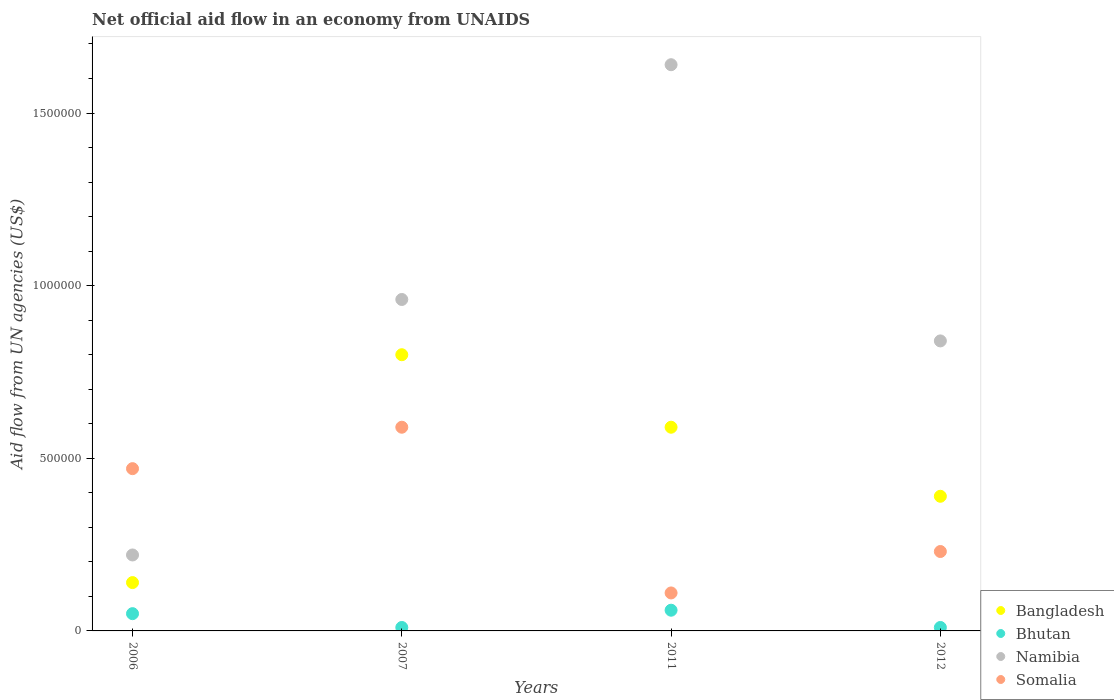What is the net official aid flow in Bangladesh in 2012?
Your response must be concise. 3.90e+05. Across all years, what is the maximum net official aid flow in Somalia?
Provide a short and direct response. 5.90e+05. In which year was the net official aid flow in Bangladesh maximum?
Ensure brevity in your answer.  2007. In which year was the net official aid flow in Bhutan minimum?
Offer a terse response. 2007. What is the total net official aid flow in Somalia in the graph?
Your answer should be very brief. 1.40e+06. What is the difference between the net official aid flow in Bangladesh in 2007 and that in 2012?
Keep it short and to the point. 4.10e+05. What is the difference between the net official aid flow in Bhutan in 2012 and the net official aid flow in Namibia in 2007?
Your answer should be compact. -9.50e+05. What is the average net official aid flow in Bhutan per year?
Ensure brevity in your answer.  3.25e+04. In the year 2006, what is the difference between the net official aid flow in Namibia and net official aid flow in Somalia?
Make the answer very short. -2.50e+05. In how many years, is the net official aid flow in Somalia greater than 1600000 US$?
Ensure brevity in your answer.  0. What is the ratio of the net official aid flow in Bangladesh in 2006 to that in 2007?
Your answer should be very brief. 0.17. Is the net official aid flow in Bhutan in 2007 less than that in 2011?
Ensure brevity in your answer.  Yes. Is it the case that in every year, the sum of the net official aid flow in Bangladesh and net official aid flow in Namibia  is greater than the sum of net official aid flow in Bhutan and net official aid flow in Somalia?
Provide a succinct answer. No. Does the net official aid flow in Somalia monotonically increase over the years?
Offer a terse response. No. How many dotlines are there?
Your response must be concise. 4. How many years are there in the graph?
Give a very brief answer. 4. What is the difference between two consecutive major ticks on the Y-axis?
Your response must be concise. 5.00e+05. Are the values on the major ticks of Y-axis written in scientific E-notation?
Make the answer very short. No. Where does the legend appear in the graph?
Make the answer very short. Bottom right. How many legend labels are there?
Make the answer very short. 4. How are the legend labels stacked?
Your answer should be compact. Vertical. What is the title of the graph?
Provide a succinct answer. Net official aid flow in an economy from UNAIDS. Does "Mongolia" appear as one of the legend labels in the graph?
Make the answer very short. No. What is the label or title of the X-axis?
Offer a terse response. Years. What is the label or title of the Y-axis?
Keep it short and to the point. Aid flow from UN agencies (US$). What is the Aid flow from UN agencies (US$) in Bangladesh in 2006?
Offer a very short reply. 1.40e+05. What is the Aid flow from UN agencies (US$) of Bhutan in 2006?
Keep it short and to the point. 5.00e+04. What is the Aid flow from UN agencies (US$) in Bangladesh in 2007?
Keep it short and to the point. 8.00e+05. What is the Aid flow from UN agencies (US$) in Bhutan in 2007?
Offer a terse response. 10000. What is the Aid flow from UN agencies (US$) in Namibia in 2007?
Provide a succinct answer. 9.60e+05. What is the Aid flow from UN agencies (US$) in Somalia in 2007?
Offer a very short reply. 5.90e+05. What is the Aid flow from UN agencies (US$) in Bangladesh in 2011?
Keep it short and to the point. 5.90e+05. What is the Aid flow from UN agencies (US$) in Namibia in 2011?
Your answer should be compact. 1.64e+06. What is the Aid flow from UN agencies (US$) of Bangladesh in 2012?
Give a very brief answer. 3.90e+05. What is the Aid flow from UN agencies (US$) of Namibia in 2012?
Offer a terse response. 8.40e+05. Across all years, what is the maximum Aid flow from UN agencies (US$) of Bangladesh?
Your answer should be compact. 8.00e+05. Across all years, what is the maximum Aid flow from UN agencies (US$) of Namibia?
Your response must be concise. 1.64e+06. Across all years, what is the maximum Aid flow from UN agencies (US$) in Somalia?
Your answer should be compact. 5.90e+05. Across all years, what is the minimum Aid flow from UN agencies (US$) in Bhutan?
Offer a very short reply. 10000. Across all years, what is the minimum Aid flow from UN agencies (US$) in Namibia?
Your answer should be compact. 2.20e+05. Across all years, what is the minimum Aid flow from UN agencies (US$) in Somalia?
Offer a terse response. 1.10e+05. What is the total Aid flow from UN agencies (US$) in Bangladesh in the graph?
Your response must be concise. 1.92e+06. What is the total Aid flow from UN agencies (US$) of Namibia in the graph?
Provide a succinct answer. 3.66e+06. What is the total Aid flow from UN agencies (US$) in Somalia in the graph?
Your answer should be compact. 1.40e+06. What is the difference between the Aid flow from UN agencies (US$) of Bangladesh in 2006 and that in 2007?
Your answer should be compact. -6.60e+05. What is the difference between the Aid flow from UN agencies (US$) of Namibia in 2006 and that in 2007?
Your answer should be compact. -7.40e+05. What is the difference between the Aid flow from UN agencies (US$) in Somalia in 2006 and that in 2007?
Make the answer very short. -1.20e+05. What is the difference between the Aid flow from UN agencies (US$) in Bangladesh in 2006 and that in 2011?
Make the answer very short. -4.50e+05. What is the difference between the Aid flow from UN agencies (US$) in Namibia in 2006 and that in 2011?
Offer a very short reply. -1.42e+06. What is the difference between the Aid flow from UN agencies (US$) in Somalia in 2006 and that in 2011?
Ensure brevity in your answer.  3.60e+05. What is the difference between the Aid flow from UN agencies (US$) in Namibia in 2006 and that in 2012?
Make the answer very short. -6.20e+05. What is the difference between the Aid flow from UN agencies (US$) of Namibia in 2007 and that in 2011?
Offer a terse response. -6.80e+05. What is the difference between the Aid flow from UN agencies (US$) in Somalia in 2007 and that in 2011?
Keep it short and to the point. 4.80e+05. What is the difference between the Aid flow from UN agencies (US$) in Bangladesh in 2007 and that in 2012?
Provide a succinct answer. 4.10e+05. What is the difference between the Aid flow from UN agencies (US$) in Somalia in 2007 and that in 2012?
Offer a terse response. 3.60e+05. What is the difference between the Aid flow from UN agencies (US$) of Bangladesh in 2011 and that in 2012?
Offer a terse response. 2.00e+05. What is the difference between the Aid flow from UN agencies (US$) in Namibia in 2011 and that in 2012?
Provide a short and direct response. 8.00e+05. What is the difference between the Aid flow from UN agencies (US$) in Bangladesh in 2006 and the Aid flow from UN agencies (US$) in Namibia in 2007?
Your answer should be very brief. -8.20e+05. What is the difference between the Aid flow from UN agencies (US$) in Bangladesh in 2006 and the Aid flow from UN agencies (US$) in Somalia in 2007?
Make the answer very short. -4.50e+05. What is the difference between the Aid flow from UN agencies (US$) in Bhutan in 2006 and the Aid flow from UN agencies (US$) in Namibia in 2007?
Keep it short and to the point. -9.10e+05. What is the difference between the Aid flow from UN agencies (US$) of Bhutan in 2006 and the Aid flow from UN agencies (US$) of Somalia in 2007?
Give a very brief answer. -5.40e+05. What is the difference between the Aid flow from UN agencies (US$) of Namibia in 2006 and the Aid flow from UN agencies (US$) of Somalia in 2007?
Keep it short and to the point. -3.70e+05. What is the difference between the Aid flow from UN agencies (US$) in Bangladesh in 2006 and the Aid flow from UN agencies (US$) in Namibia in 2011?
Offer a very short reply. -1.50e+06. What is the difference between the Aid flow from UN agencies (US$) of Bhutan in 2006 and the Aid flow from UN agencies (US$) of Namibia in 2011?
Keep it short and to the point. -1.59e+06. What is the difference between the Aid flow from UN agencies (US$) of Bhutan in 2006 and the Aid flow from UN agencies (US$) of Somalia in 2011?
Give a very brief answer. -6.00e+04. What is the difference between the Aid flow from UN agencies (US$) of Bangladesh in 2006 and the Aid flow from UN agencies (US$) of Namibia in 2012?
Offer a very short reply. -7.00e+05. What is the difference between the Aid flow from UN agencies (US$) of Bhutan in 2006 and the Aid flow from UN agencies (US$) of Namibia in 2012?
Your answer should be compact. -7.90e+05. What is the difference between the Aid flow from UN agencies (US$) in Bhutan in 2006 and the Aid flow from UN agencies (US$) in Somalia in 2012?
Provide a short and direct response. -1.80e+05. What is the difference between the Aid flow from UN agencies (US$) of Namibia in 2006 and the Aid flow from UN agencies (US$) of Somalia in 2012?
Provide a short and direct response. -10000. What is the difference between the Aid flow from UN agencies (US$) of Bangladesh in 2007 and the Aid flow from UN agencies (US$) of Bhutan in 2011?
Your answer should be compact. 7.40e+05. What is the difference between the Aid flow from UN agencies (US$) in Bangladesh in 2007 and the Aid flow from UN agencies (US$) in Namibia in 2011?
Keep it short and to the point. -8.40e+05. What is the difference between the Aid flow from UN agencies (US$) in Bangladesh in 2007 and the Aid flow from UN agencies (US$) in Somalia in 2011?
Keep it short and to the point. 6.90e+05. What is the difference between the Aid flow from UN agencies (US$) of Bhutan in 2007 and the Aid flow from UN agencies (US$) of Namibia in 2011?
Offer a very short reply. -1.63e+06. What is the difference between the Aid flow from UN agencies (US$) of Bhutan in 2007 and the Aid flow from UN agencies (US$) of Somalia in 2011?
Your answer should be compact. -1.00e+05. What is the difference between the Aid flow from UN agencies (US$) in Namibia in 2007 and the Aid flow from UN agencies (US$) in Somalia in 2011?
Provide a short and direct response. 8.50e+05. What is the difference between the Aid flow from UN agencies (US$) in Bangladesh in 2007 and the Aid flow from UN agencies (US$) in Bhutan in 2012?
Offer a terse response. 7.90e+05. What is the difference between the Aid flow from UN agencies (US$) in Bangladesh in 2007 and the Aid flow from UN agencies (US$) in Namibia in 2012?
Offer a very short reply. -4.00e+04. What is the difference between the Aid flow from UN agencies (US$) in Bangladesh in 2007 and the Aid flow from UN agencies (US$) in Somalia in 2012?
Make the answer very short. 5.70e+05. What is the difference between the Aid flow from UN agencies (US$) in Bhutan in 2007 and the Aid flow from UN agencies (US$) in Namibia in 2012?
Offer a very short reply. -8.30e+05. What is the difference between the Aid flow from UN agencies (US$) of Namibia in 2007 and the Aid flow from UN agencies (US$) of Somalia in 2012?
Give a very brief answer. 7.30e+05. What is the difference between the Aid flow from UN agencies (US$) of Bangladesh in 2011 and the Aid flow from UN agencies (US$) of Bhutan in 2012?
Offer a very short reply. 5.80e+05. What is the difference between the Aid flow from UN agencies (US$) in Bangladesh in 2011 and the Aid flow from UN agencies (US$) in Namibia in 2012?
Keep it short and to the point. -2.50e+05. What is the difference between the Aid flow from UN agencies (US$) of Bangladesh in 2011 and the Aid flow from UN agencies (US$) of Somalia in 2012?
Keep it short and to the point. 3.60e+05. What is the difference between the Aid flow from UN agencies (US$) in Bhutan in 2011 and the Aid flow from UN agencies (US$) in Namibia in 2012?
Make the answer very short. -7.80e+05. What is the difference between the Aid flow from UN agencies (US$) in Bhutan in 2011 and the Aid flow from UN agencies (US$) in Somalia in 2012?
Provide a short and direct response. -1.70e+05. What is the difference between the Aid flow from UN agencies (US$) of Namibia in 2011 and the Aid flow from UN agencies (US$) of Somalia in 2012?
Your answer should be very brief. 1.41e+06. What is the average Aid flow from UN agencies (US$) of Bhutan per year?
Offer a terse response. 3.25e+04. What is the average Aid flow from UN agencies (US$) in Namibia per year?
Keep it short and to the point. 9.15e+05. What is the average Aid flow from UN agencies (US$) in Somalia per year?
Provide a short and direct response. 3.50e+05. In the year 2006, what is the difference between the Aid flow from UN agencies (US$) of Bangladesh and Aid flow from UN agencies (US$) of Bhutan?
Your answer should be very brief. 9.00e+04. In the year 2006, what is the difference between the Aid flow from UN agencies (US$) of Bangladesh and Aid flow from UN agencies (US$) of Somalia?
Ensure brevity in your answer.  -3.30e+05. In the year 2006, what is the difference between the Aid flow from UN agencies (US$) of Bhutan and Aid flow from UN agencies (US$) of Namibia?
Ensure brevity in your answer.  -1.70e+05. In the year 2006, what is the difference between the Aid flow from UN agencies (US$) of Bhutan and Aid flow from UN agencies (US$) of Somalia?
Provide a short and direct response. -4.20e+05. In the year 2006, what is the difference between the Aid flow from UN agencies (US$) in Namibia and Aid flow from UN agencies (US$) in Somalia?
Provide a succinct answer. -2.50e+05. In the year 2007, what is the difference between the Aid flow from UN agencies (US$) in Bangladesh and Aid flow from UN agencies (US$) in Bhutan?
Provide a short and direct response. 7.90e+05. In the year 2007, what is the difference between the Aid flow from UN agencies (US$) in Bhutan and Aid flow from UN agencies (US$) in Namibia?
Ensure brevity in your answer.  -9.50e+05. In the year 2007, what is the difference between the Aid flow from UN agencies (US$) of Bhutan and Aid flow from UN agencies (US$) of Somalia?
Your answer should be very brief. -5.80e+05. In the year 2011, what is the difference between the Aid flow from UN agencies (US$) of Bangladesh and Aid flow from UN agencies (US$) of Bhutan?
Offer a terse response. 5.30e+05. In the year 2011, what is the difference between the Aid flow from UN agencies (US$) of Bangladesh and Aid flow from UN agencies (US$) of Namibia?
Make the answer very short. -1.05e+06. In the year 2011, what is the difference between the Aid flow from UN agencies (US$) in Bangladesh and Aid flow from UN agencies (US$) in Somalia?
Ensure brevity in your answer.  4.80e+05. In the year 2011, what is the difference between the Aid flow from UN agencies (US$) of Bhutan and Aid flow from UN agencies (US$) of Namibia?
Make the answer very short. -1.58e+06. In the year 2011, what is the difference between the Aid flow from UN agencies (US$) of Namibia and Aid flow from UN agencies (US$) of Somalia?
Your answer should be compact. 1.53e+06. In the year 2012, what is the difference between the Aid flow from UN agencies (US$) of Bangladesh and Aid flow from UN agencies (US$) of Namibia?
Your response must be concise. -4.50e+05. In the year 2012, what is the difference between the Aid flow from UN agencies (US$) of Bangladesh and Aid flow from UN agencies (US$) of Somalia?
Offer a terse response. 1.60e+05. In the year 2012, what is the difference between the Aid flow from UN agencies (US$) in Bhutan and Aid flow from UN agencies (US$) in Namibia?
Provide a succinct answer. -8.30e+05. In the year 2012, what is the difference between the Aid flow from UN agencies (US$) of Namibia and Aid flow from UN agencies (US$) of Somalia?
Give a very brief answer. 6.10e+05. What is the ratio of the Aid flow from UN agencies (US$) of Bangladesh in 2006 to that in 2007?
Your answer should be compact. 0.17. What is the ratio of the Aid flow from UN agencies (US$) in Namibia in 2006 to that in 2007?
Ensure brevity in your answer.  0.23. What is the ratio of the Aid flow from UN agencies (US$) in Somalia in 2006 to that in 2007?
Your answer should be very brief. 0.8. What is the ratio of the Aid flow from UN agencies (US$) in Bangladesh in 2006 to that in 2011?
Ensure brevity in your answer.  0.24. What is the ratio of the Aid flow from UN agencies (US$) of Namibia in 2006 to that in 2011?
Your answer should be compact. 0.13. What is the ratio of the Aid flow from UN agencies (US$) in Somalia in 2006 to that in 2011?
Make the answer very short. 4.27. What is the ratio of the Aid flow from UN agencies (US$) in Bangladesh in 2006 to that in 2012?
Give a very brief answer. 0.36. What is the ratio of the Aid flow from UN agencies (US$) in Namibia in 2006 to that in 2012?
Your answer should be very brief. 0.26. What is the ratio of the Aid flow from UN agencies (US$) in Somalia in 2006 to that in 2012?
Ensure brevity in your answer.  2.04. What is the ratio of the Aid flow from UN agencies (US$) of Bangladesh in 2007 to that in 2011?
Provide a succinct answer. 1.36. What is the ratio of the Aid flow from UN agencies (US$) in Bhutan in 2007 to that in 2011?
Give a very brief answer. 0.17. What is the ratio of the Aid flow from UN agencies (US$) in Namibia in 2007 to that in 2011?
Provide a succinct answer. 0.59. What is the ratio of the Aid flow from UN agencies (US$) of Somalia in 2007 to that in 2011?
Your response must be concise. 5.36. What is the ratio of the Aid flow from UN agencies (US$) of Bangladesh in 2007 to that in 2012?
Offer a terse response. 2.05. What is the ratio of the Aid flow from UN agencies (US$) in Namibia in 2007 to that in 2012?
Keep it short and to the point. 1.14. What is the ratio of the Aid flow from UN agencies (US$) in Somalia in 2007 to that in 2012?
Provide a short and direct response. 2.57. What is the ratio of the Aid flow from UN agencies (US$) in Bangladesh in 2011 to that in 2012?
Provide a short and direct response. 1.51. What is the ratio of the Aid flow from UN agencies (US$) of Bhutan in 2011 to that in 2012?
Provide a succinct answer. 6. What is the ratio of the Aid flow from UN agencies (US$) in Namibia in 2011 to that in 2012?
Give a very brief answer. 1.95. What is the ratio of the Aid flow from UN agencies (US$) of Somalia in 2011 to that in 2012?
Provide a succinct answer. 0.48. What is the difference between the highest and the second highest Aid flow from UN agencies (US$) in Namibia?
Your answer should be compact. 6.80e+05. What is the difference between the highest and the second highest Aid flow from UN agencies (US$) in Somalia?
Your answer should be very brief. 1.20e+05. What is the difference between the highest and the lowest Aid flow from UN agencies (US$) in Bangladesh?
Provide a succinct answer. 6.60e+05. What is the difference between the highest and the lowest Aid flow from UN agencies (US$) of Bhutan?
Offer a terse response. 5.00e+04. What is the difference between the highest and the lowest Aid flow from UN agencies (US$) of Namibia?
Your answer should be compact. 1.42e+06. What is the difference between the highest and the lowest Aid flow from UN agencies (US$) of Somalia?
Provide a short and direct response. 4.80e+05. 